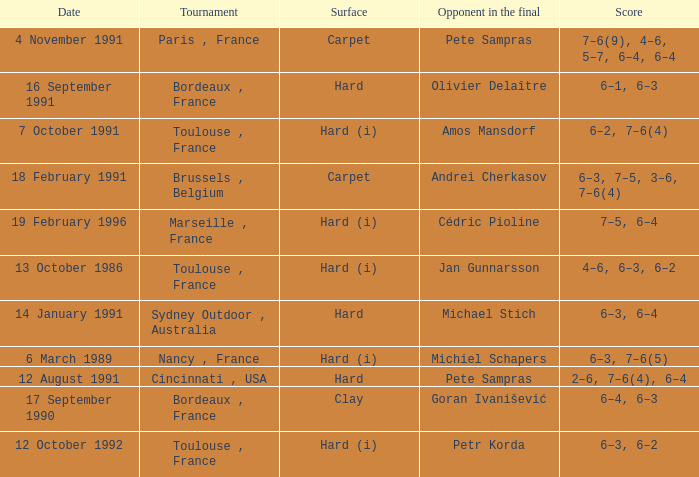What is the surface of the tournament with cédric pioline as the opponent in the final? Hard (i). 